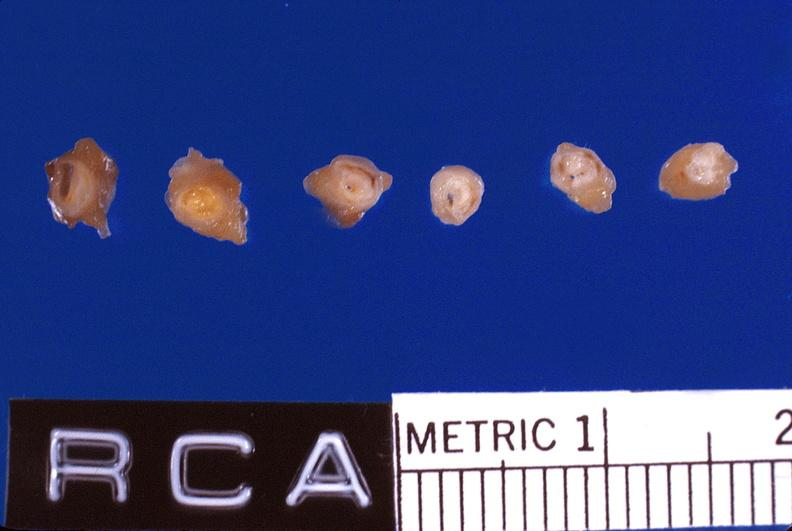does this image show atherosclerosis, right coronary artery?
Answer the question using a single word or phrase. Yes 